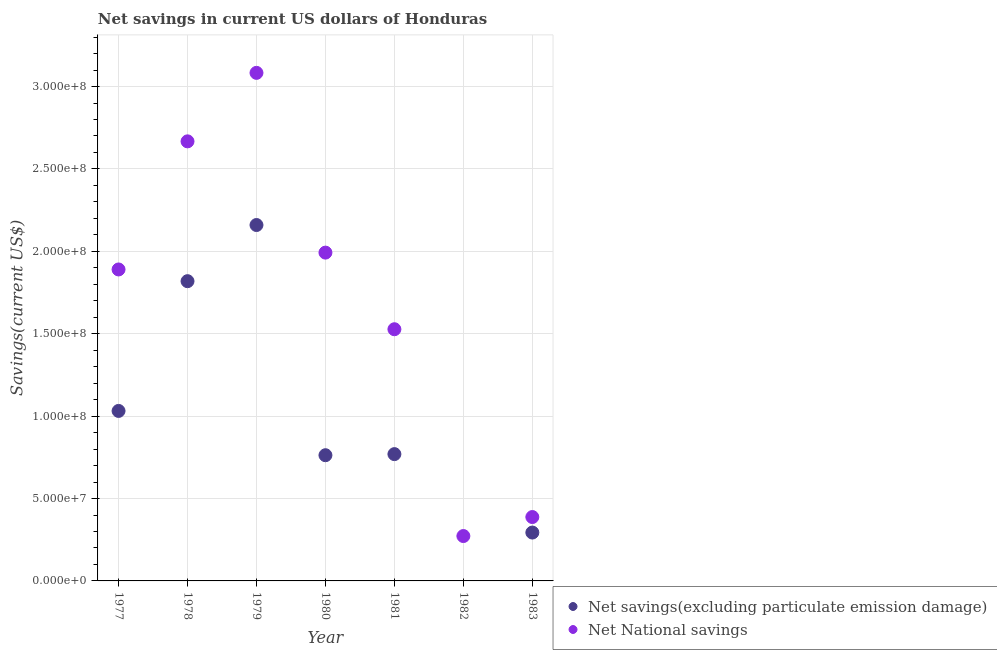Is the number of dotlines equal to the number of legend labels?
Your answer should be very brief. No. What is the net national savings in 1979?
Keep it short and to the point. 3.08e+08. Across all years, what is the maximum net savings(excluding particulate emission damage)?
Give a very brief answer. 2.16e+08. In which year was the net savings(excluding particulate emission damage) maximum?
Provide a succinct answer. 1979. What is the total net savings(excluding particulate emission damage) in the graph?
Keep it short and to the point. 6.84e+08. What is the difference between the net savings(excluding particulate emission damage) in 1977 and that in 1983?
Make the answer very short. 7.38e+07. What is the difference between the net savings(excluding particulate emission damage) in 1983 and the net national savings in 1980?
Make the answer very short. -1.70e+08. What is the average net savings(excluding particulate emission damage) per year?
Offer a terse response. 9.77e+07. In the year 1978, what is the difference between the net national savings and net savings(excluding particulate emission damage)?
Your answer should be compact. 8.49e+07. In how many years, is the net national savings greater than 10000000 US$?
Offer a terse response. 7. What is the ratio of the net national savings in 1981 to that in 1983?
Your answer should be very brief. 3.94. Is the difference between the net savings(excluding particulate emission damage) in 1980 and 1981 greater than the difference between the net national savings in 1980 and 1981?
Keep it short and to the point. No. What is the difference between the highest and the second highest net national savings?
Make the answer very short. 4.16e+07. What is the difference between the highest and the lowest net savings(excluding particulate emission damage)?
Your response must be concise. 2.16e+08. In how many years, is the net national savings greater than the average net national savings taken over all years?
Your answer should be compact. 4. Does the net savings(excluding particulate emission damage) monotonically increase over the years?
Make the answer very short. No. Is the net national savings strictly less than the net savings(excluding particulate emission damage) over the years?
Offer a very short reply. No. How many years are there in the graph?
Keep it short and to the point. 7. What is the difference between two consecutive major ticks on the Y-axis?
Your answer should be compact. 5.00e+07. Does the graph contain any zero values?
Offer a very short reply. Yes. Does the graph contain grids?
Offer a very short reply. Yes. Where does the legend appear in the graph?
Give a very brief answer. Bottom right. How many legend labels are there?
Provide a short and direct response. 2. What is the title of the graph?
Your response must be concise. Net savings in current US dollars of Honduras. Does "Goods and services" appear as one of the legend labels in the graph?
Provide a succinct answer. No. What is the label or title of the X-axis?
Provide a short and direct response. Year. What is the label or title of the Y-axis?
Keep it short and to the point. Savings(current US$). What is the Savings(current US$) in Net savings(excluding particulate emission damage) in 1977?
Your response must be concise. 1.03e+08. What is the Savings(current US$) in Net National savings in 1977?
Provide a succinct answer. 1.89e+08. What is the Savings(current US$) of Net savings(excluding particulate emission damage) in 1978?
Give a very brief answer. 1.82e+08. What is the Savings(current US$) of Net National savings in 1978?
Your answer should be very brief. 2.67e+08. What is the Savings(current US$) in Net savings(excluding particulate emission damage) in 1979?
Give a very brief answer. 2.16e+08. What is the Savings(current US$) in Net National savings in 1979?
Offer a very short reply. 3.08e+08. What is the Savings(current US$) in Net savings(excluding particulate emission damage) in 1980?
Keep it short and to the point. 7.63e+07. What is the Savings(current US$) in Net National savings in 1980?
Provide a short and direct response. 1.99e+08. What is the Savings(current US$) of Net savings(excluding particulate emission damage) in 1981?
Keep it short and to the point. 7.69e+07. What is the Savings(current US$) of Net National savings in 1981?
Your answer should be compact. 1.53e+08. What is the Savings(current US$) in Net savings(excluding particulate emission damage) in 1982?
Make the answer very short. 0. What is the Savings(current US$) in Net National savings in 1982?
Offer a very short reply. 2.72e+07. What is the Savings(current US$) of Net savings(excluding particulate emission damage) in 1983?
Offer a very short reply. 2.94e+07. What is the Savings(current US$) in Net National savings in 1983?
Your answer should be very brief. 3.88e+07. Across all years, what is the maximum Savings(current US$) in Net savings(excluding particulate emission damage)?
Your answer should be compact. 2.16e+08. Across all years, what is the maximum Savings(current US$) in Net National savings?
Your response must be concise. 3.08e+08. Across all years, what is the minimum Savings(current US$) in Net National savings?
Offer a very short reply. 2.72e+07. What is the total Savings(current US$) in Net savings(excluding particulate emission damage) in the graph?
Your answer should be very brief. 6.84e+08. What is the total Savings(current US$) in Net National savings in the graph?
Make the answer very short. 1.18e+09. What is the difference between the Savings(current US$) of Net savings(excluding particulate emission damage) in 1977 and that in 1978?
Ensure brevity in your answer.  -7.87e+07. What is the difference between the Savings(current US$) in Net National savings in 1977 and that in 1978?
Keep it short and to the point. -7.77e+07. What is the difference between the Savings(current US$) of Net savings(excluding particulate emission damage) in 1977 and that in 1979?
Your answer should be compact. -1.13e+08. What is the difference between the Savings(current US$) in Net National savings in 1977 and that in 1979?
Ensure brevity in your answer.  -1.19e+08. What is the difference between the Savings(current US$) of Net savings(excluding particulate emission damage) in 1977 and that in 1980?
Make the answer very short. 2.69e+07. What is the difference between the Savings(current US$) of Net National savings in 1977 and that in 1980?
Your answer should be very brief. -1.02e+07. What is the difference between the Savings(current US$) in Net savings(excluding particulate emission damage) in 1977 and that in 1981?
Provide a short and direct response. 2.62e+07. What is the difference between the Savings(current US$) of Net National savings in 1977 and that in 1981?
Your response must be concise. 3.63e+07. What is the difference between the Savings(current US$) in Net National savings in 1977 and that in 1982?
Provide a short and direct response. 1.62e+08. What is the difference between the Savings(current US$) in Net savings(excluding particulate emission damage) in 1977 and that in 1983?
Offer a terse response. 7.38e+07. What is the difference between the Savings(current US$) in Net National savings in 1977 and that in 1983?
Give a very brief answer. 1.50e+08. What is the difference between the Savings(current US$) of Net savings(excluding particulate emission damage) in 1978 and that in 1979?
Provide a short and direct response. -3.41e+07. What is the difference between the Savings(current US$) in Net National savings in 1978 and that in 1979?
Offer a very short reply. -4.16e+07. What is the difference between the Savings(current US$) in Net savings(excluding particulate emission damage) in 1978 and that in 1980?
Offer a terse response. 1.06e+08. What is the difference between the Savings(current US$) in Net National savings in 1978 and that in 1980?
Offer a very short reply. 6.75e+07. What is the difference between the Savings(current US$) of Net savings(excluding particulate emission damage) in 1978 and that in 1981?
Provide a short and direct response. 1.05e+08. What is the difference between the Savings(current US$) of Net National savings in 1978 and that in 1981?
Provide a short and direct response. 1.14e+08. What is the difference between the Savings(current US$) of Net National savings in 1978 and that in 1982?
Offer a terse response. 2.40e+08. What is the difference between the Savings(current US$) of Net savings(excluding particulate emission damage) in 1978 and that in 1983?
Offer a terse response. 1.53e+08. What is the difference between the Savings(current US$) of Net National savings in 1978 and that in 1983?
Provide a succinct answer. 2.28e+08. What is the difference between the Savings(current US$) of Net savings(excluding particulate emission damage) in 1979 and that in 1980?
Offer a very short reply. 1.40e+08. What is the difference between the Savings(current US$) in Net National savings in 1979 and that in 1980?
Your answer should be very brief. 1.09e+08. What is the difference between the Savings(current US$) in Net savings(excluding particulate emission damage) in 1979 and that in 1981?
Offer a terse response. 1.39e+08. What is the difference between the Savings(current US$) of Net National savings in 1979 and that in 1981?
Provide a short and direct response. 1.56e+08. What is the difference between the Savings(current US$) in Net National savings in 1979 and that in 1982?
Ensure brevity in your answer.  2.81e+08. What is the difference between the Savings(current US$) of Net savings(excluding particulate emission damage) in 1979 and that in 1983?
Ensure brevity in your answer.  1.87e+08. What is the difference between the Savings(current US$) of Net National savings in 1979 and that in 1983?
Provide a short and direct response. 2.70e+08. What is the difference between the Savings(current US$) of Net savings(excluding particulate emission damage) in 1980 and that in 1981?
Ensure brevity in your answer.  -6.65e+05. What is the difference between the Savings(current US$) of Net National savings in 1980 and that in 1981?
Your answer should be very brief. 4.65e+07. What is the difference between the Savings(current US$) of Net National savings in 1980 and that in 1982?
Make the answer very short. 1.72e+08. What is the difference between the Savings(current US$) in Net savings(excluding particulate emission damage) in 1980 and that in 1983?
Offer a very short reply. 4.69e+07. What is the difference between the Savings(current US$) in Net National savings in 1980 and that in 1983?
Offer a terse response. 1.60e+08. What is the difference between the Savings(current US$) in Net National savings in 1981 and that in 1982?
Your answer should be compact. 1.26e+08. What is the difference between the Savings(current US$) of Net savings(excluding particulate emission damage) in 1981 and that in 1983?
Your answer should be compact. 4.76e+07. What is the difference between the Savings(current US$) in Net National savings in 1981 and that in 1983?
Make the answer very short. 1.14e+08. What is the difference between the Savings(current US$) in Net National savings in 1982 and that in 1983?
Give a very brief answer. -1.15e+07. What is the difference between the Savings(current US$) in Net savings(excluding particulate emission damage) in 1977 and the Savings(current US$) in Net National savings in 1978?
Make the answer very short. -1.64e+08. What is the difference between the Savings(current US$) in Net savings(excluding particulate emission damage) in 1977 and the Savings(current US$) in Net National savings in 1979?
Your answer should be compact. -2.05e+08. What is the difference between the Savings(current US$) of Net savings(excluding particulate emission damage) in 1977 and the Savings(current US$) of Net National savings in 1980?
Your answer should be very brief. -9.61e+07. What is the difference between the Savings(current US$) of Net savings(excluding particulate emission damage) in 1977 and the Savings(current US$) of Net National savings in 1981?
Keep it short and to the point. -4.96e+07. What is the difference between the Savings(current US$) of Net savings(excluding particulate emission damage) in 1977 and the Savings(current US$) of Net National savings in 1982?
Ensure brevity in your answer.  7.59e+07. What is the difference between the Savings(current US$) of Net savings(excluding particulate emission damage) in 1977 and the Savings(current US$) of Net National savings in 1983?
Your answer should be compact. 6.44e+07. What is the difference between the Savings(current US$) of Net savings(excluding particulate emission damage) in 1978 and the Savings(current US$) of Net National savings in 1979?
Offer a terse response. -1.26e+08. What is the difference between the Savings(current US$) in Net savings(excluding particulate emission damage) in 1978 and the Savings(current US$) in Net National savings in 1980?
Offer a terse response. -1.73e+07. What is the difference between the Savings(current US$) in Net savings(excluding particulate emission damage) in 1978 and the Savings(current US$) in Net National savings in 1981?
Your answer should be very brief. 2.92e+07. What is the difference between the Savings(current US$) in Net savings(excluding particulate emission damage) in 1978 and the Savings(current US$) in Net National savings in 1982?
Your answer should be compact. 1.55e+08. What is the difference between the Savings(current US$) of Net savings(excluding particulate emission damage) in 1978 and the Savings(current US$) of Net National savings in 1983?
Your response must be concise. 1.43e+08. What is the difference between the Savings(current US$) of Net savings(excluding particulate emission damage) in 1979 and the Savings(current US$) of Net National savings in 1980?
Your response must be concise. 1.67e+07. What is the difference between the Savings(current US$) in Net savings(excluding particulate emission damage) in 1979 and the Savings(current US$) in Net National savings in 1981?
Your answer should be very brief. 6.32e+07. What is the difference between the Savings(current US$) in Net savings(excluding particulate emission damage) in 1979 and the Savings(current US$) in Net National savings in 1982?
Your response must be concise. 1.89e+08. What is the difference between the Savings(current US$) in Net savings(excluding particulate emission damage) in 1979 and the Savings(current US$) in Net National savings in 1983?
Ensure brevity in your answer.  1.77e+08. What is the difference between the Savings(current US$) in Net savings(excluding particulate emission damage) in 1980 and the Savings(current US$) in Net National savings in 1981?
Ensure brevity in your answer.  -7.65e+07. What is the difference between the Savings(current US$) in Net savings(excluding particulate emission damage) in 1980 and the Savings(current US$) in Net National savings in 1982?
Provide a short and direct response. 4.90e+07. What is the difference between the Savings(current US$) of Net savings(excluding particulate emission damage) in 1980 and the Savings(current US$) of Net National savings in 1983?
Provide a short and direct response. 3.75e+07. What is the difference between the Savings(current US$) of Net savings(excluding particulate emission damage) in 1981 and the Savings(current US$) of Net National savings in 1982?
Offer a very short reply. 4.97e+07. What is the difference between the Savings(current US$) of Net savings(excluding particulate emission damage) in 1981 and the Savings(current US$) of Net National savings in 1983?
Offer a very short reply. 3.82e+07. What is the average Savings(current US$) of Net savings(excluding particulate emission damage) per year?
Your answer should be very brief. 9.77e+07. What is the average Savings(current US$) of Net National savings per year?
Your answer should be compact. 1.69e+08. In the year 1977, what is the difference between the Savings(current US$) of Net savings(excluding particulate emission damage) and Savings(current US$) of Net National savings?
Offer a very short reply. -8.59e+07. In the year 1978, what is the difference between the Savings(current US$) of Net savings(excluding particulate emission damage) and Savings(current US$) of Net National savings?
Make the answer very short. -8.49e+07. In the year 1979, what is the difference between the Savings(current US$) in Net savings(excluding particulate emission damage) and Savings(current US$) in Net National savings?
Give a very brief answer. -9.23e+07. In the year 1980, what is the difference between the Savings(current US$) in Net savings(excluding particulate emission damage) and Savings(current US$) in Net National savings?
Offer a terse response. -1.23e+08. In the year 1981, what is the difference between the Savings(current US$) in Net savings(excluding particulate emission damage) and Savings(current US$) in Net National savings?
Offer a very short reply. -7.58e+07. In the year 1983, what is the difference between the Savings(current US$) of Net savings(excluding particulate emission damage) and Savings(current US$) of Net National savings?
Ensure brevity in your answer.  -9.41e+06. What is the ratio of the Savings(current US$) of Net savings(excluding particulate emission damage) in 1977 to that in 1978?
Your response must be concise. 0.57. What is the ratio of the Savings(current US$) in Net National savings in 1977 to that in 1978?
Give a very brief answer. 0.71. What is the ratio of the Savings(current US$) in Net savings(excluding particulate emission damage) in 1977 to that in 1979?
Keep it short and to the point. 0.48. What is the ratio of the Savings(current US$) of Net National savings in 1977 to that in 1979?
Offer a very short reply. 0.61. What is the ratio of the Savings(current US$) in Net savings(excluding particulate emission damage) in 1977 to that in 1980?
Your answer should be compact. 1.35. What is the ratio of the Savings(current US$) of Net National savings in 1977 to that in 1980?
Make the answer very short. 0.95. What is the ratio of the Savings(current US$) in Net savings(excluding particulate emission damage) in 1977 to that in 1981?
Keep it short and to the point. 1.34. What is the ratio of the Savings(current US$) of Net National savings in 1977 to that in 1981?
Your answer should be compact. 1.24. What is the ratio of the Savings(current US$) in Net National savings in 1977 to that in 1982?
Your answer should be compact. 6.94. What is the ratio of the Savings(current US$) of Net savings(excluding particulate emission damage) in 1977 to that in 1983?
Make the answer very short. 3.51. What is the ratio of the Savings(current US$) of Net National savings in 1977 to that in 1983?
Give a very brief answer. 4.88. What is the ratio of the Savings(current US$) of Net savings(excluding particulate emission damage) in 1978 to that in 1979?
Give a very brief answer. 0.84. What is the ratio of the Savings(current US$) of Net National savings in 1978 to that in 1979?
Your response must be concise. 0.87. What is the ratio of the Savings(current US$) in Net savings(excluding particulate emission damage) in 1978 to that in 1980?
Offer a very short reply. 2.38. What is the ratio of the Savings(current US$) in Net National savings in 1978 to that in 1980?
Your response must be concise. 1.34. What is the ratio of the Savings(current US$) in Net savings(excluding particulate emission damage) in 1978 to that in 1981?
Give a very brief answer. 2.36. What is the ratio of the Savings(current US$) in Net National savings in 1978 to that in 1981?
Provide a succinct answer. 1.75. What is the ratio of the Savings(current US$) of Net National savings in 1978 to that in 1982?
Your response must be concise. 9.8. What is the ratio of the Savings(current US$) in Net savings(excluding particulate emission damage) in 1978 to that in 1983?
Keep it short and to the point. 6.2. What is the ratio of the Savings(current US$) of Net National savings in 1978 to that in 1983?
Offer a very short reply. 6.88. What is the ratio of the Savings(current US$) of Net savings(excluding particulate emission damage) in 1979 to that in 1980?
Your answer should be compact. 2.83. What is the ratio of the Savings(current US$) in Net National savings in 1979 to that in 1980?
Offer a very short reply. 1.55. What is the ratio of the Savings(current US$) in Net savings(excluding particulate emission damage) in 1979 to that in 1981?
Your answer should be very brief. 2.81. What is the ratio of the Savings(current US$) of Net National savings in 1979 to that in 1981?
Make the answer very short. 2.02. What is the ratio of the Savings(current US$) in Net National savings in 1979 to that in 1982?
Offer a very short reply. 11.32. What is the ratio of the Savings(current US$) of Net savings(excluding particulate emission damage) in 1979 to that in 1983?
Provide a succinct answer. 7.36. What is the ratio of the Savings(current US$) of Net National savings in 1979 to that in 1983?
Offer a very short reply. 7.95. What is the ratio of the Savings(current US$) of Net savings(excluding particulate emission damage) in 1980 to that in 1981?
Give a very brief answer. 0.99. What is the ratio of the Savings(current US$) of Net National savings in 1980 to that in 1981?
Offer a very short reply. 1.3. What is the ratio of the Savings(current US$) of Net National savings in 1980 to that in 1982?
Your answer should be compact. 7.32. What is the ratio of the Savings(current US$) in Net savings(excluding particulate emission damage) in 1980 to that in 1983?
Make the answer very short. 2.6. What is the ratio of the Savings(current US$) in Net National savings in 1980 to that in 1983?
Ensure brevity in your answer.  5.14. What is the ratio of the Savings(current US$) in Net National savings in 1981 to that in 1982?
Give a very brief answer. 5.61. What is the ratio of the Savings(current US$) in Net savings(excluding particulate emission damage) in 1981 to that in 1983?
Provide a short and direct response. 2.62. What is the ratio of the Savings(current US$) in Net National savings in 1981 to that in 1983?
Provide a succinct answer. 3.94. What is the ratio of the Savings(current US$) of Net National savings in 1982 to that in 1983?
Your response must be concise. 0.7. What is the difference between the highest and the second highest Savings(current US$) of Net savings(excluding particulate emission damage)?
Offer a terse response. 3.41e+07. What is the difference between the highest and the second highest Savings(current US$) in Net National savings?
Offer a terse response. 4.16e+07. What is the difference between the highest and the lowest Savings(current US$) in Net savings(excluding particulate emission damage)?
Provide a succinct answer. 2.16e+08. What is the difference between the highest and the lowest Savings(current US$) in Net National savings?
Offer a very short reply. 2.81e+08. 